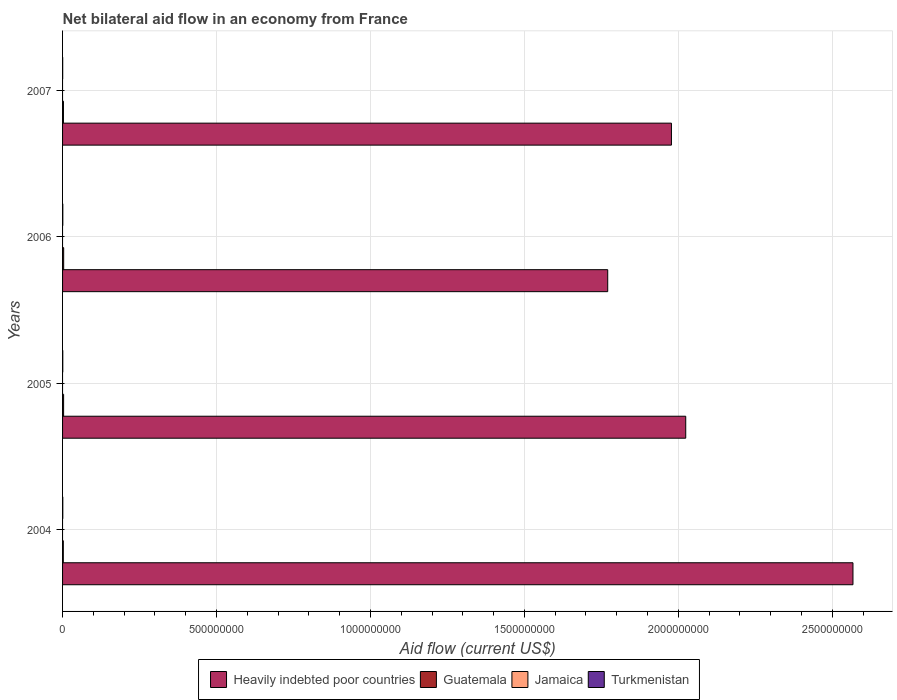How many different coloured bars are there?
Make the answer very short. 3. How many bars are there on the 4th tick from the top?
Ensure brevity in your answer.  3. What is the label of the 4th group of bars from the top?
Offer a terse response. 2004. What is the net bilateral aid flow in Turkmenistan in 2005?
Your answer should be compact. 6.80e+05. Across all years, what is the minimum net bilateral aid flow in Guatemala?
Your answer should be compact. 2.41e+06. In which year was the net bilateral aid flow in Turkmenistan maximum?
Make the answer very short. 2006. What is the total net bilateral aid flow in Guatemala in the graph?
Make the answer very short. 1.22e+07. What is the difference between the net bilateral aid flow in Guatemala in 2005 and that in 2007?
Keep it short and to the point. 5.10e+05. What is the difference between the net bilateral aid flow in Guatemala in 2005 and the net bilateral aid flow in Heavily indebted poor countries in 2007?
Offer a terse response. -1.97e+09. What is the average net bilateral aid flow in Guatemala per year?
Provide a short and direct response. 3.06e+06. In the year 2004, what is the difference between the net bilateral aid flow in Turkmenistan and net bilateral aid flow in Guatemala?
Your response must be concise. -1.64e+06. In how many years, is the net bilateral aid flow in Guatemala greater than 2000000000 US$?
Make the answer very short. 0. What is the ratio of the net bilateral aid flow in Turkmenistan in 2004 to that in 2006?
Offer a terse response. 0.96. What is the difference between the highest and the lowest net bilateral aid flow in Turkmenistan?
Your response must be concise. 4.20e+05. Is it the case that in every year, the sum of the net bilateral aid flow in Turkmenistan and net bilateral aid flow in Jamaica is greater than the net bilateral aid flow in Guatemala?
Keep it short and to the point. No. How many bars are there?
Ensure brevity in your answer.  12. Are all the bars in the graph horizontal?
Provide a succinct answer. Yes. Does the graph contain any zero values?
Keep it short and to the point. Yes. Does the graph contain grids?
Ensure brevity in your answer.  Yes. Where does the legend appear in the graph?
Offer a terse response. Bottom center. What is the title of the graph?
Offer a terse response. Net bilateral aid flow in an economy from France. What is the label or title of the X-axis?
Keep it short and to the point. Aid flow (current US$). What is the Aid flow (current US$) in Heavily indebted poor countries in 2004?
Your answer should be very brief. 2.57e+09. What is the Aid flow (current US$) of Guatemala in 2004?
Give a very brief answer. 2.41e+06. What is the Aid flow (current US$) of Jamaica in 2004?
Ensure brevity in your answer.  0. What is the Aid flow (current US$) of Turkmenistan in 2004?
Provide a short and direct response. 7.70e+05. What is the Aid flow (current US$) in Heavily indebted poor countries in 2005?
Your answer should be compact. 2.02e+09. What is the Aid flow (current US$) of Guatemala in 2005?
Provide a succinct answer. 3.37e+06. What is the Aid flow (current US$) of Turkmenistan in 2005?
Your response must be concise. 6.80e+05. What is the Aid flow (current US$) of Heavily indebted poor countries in 2006?
Your answer should be very brief. 1.77e+09. What is the Aid flow (current US$) in Guatemala in 2006?
Your response must be concise. 3.59e+06. What is the Aid flow (current US$) of Heavily indebted poor countries in 2007?
Offer a very short reply. 1.98e+09. What is the Aid flow (current US$) in Guatemala in 2007?
Keep it short and to the point. 2.86e+06. What is the Aid flow (current US$) in Jamaica in 2007?
Provide a short and direct response. 0. Across all years, what is the maximum Aid flow (current US$) of Heavily indebted poor countries?
Ensure brevity in your answer.  2.57e+09. Across all years, what is the maximum Aid flow (current US$) of Guatemala?
Your response must be concise. 3.59e+06. Across all years, what is the minimum Aid flow (current US$) of Heavily indebted poor countries?
Keep it short and to the point. 1.77e+09. Across all years, what is the minimum Aid flow (current US$) in Guatemala?
Keep it short and to the point. 2.41e+06. Across all years, what is the minimum Aid flow (current US$) of Turkmenistan?
Ensure brevity in your answer.  3.80e+05. What is the total Aid flow (current US$) of Heavily indebted poor countries in the graph?
Give a very brief answer. 8.34e+09. What is the total Aid flow (current US$) in Guatemala in the graph?
Your answer should be very brief. 1.22e+07. What is the total Aid flow (current US$) in Turkmenistan in the graph?
Your answer should be compact. 2.63e+06. What is the difference between the Aid flow (current US$) in Heavily indebted poor countries in 2004 and that in 2005?
Make the answer very short. 5.43e+08. What is the difference between the Aid flow (current US$) of Guatemala in 2004 and that in 2005?
Ensure brevity in your answer.  -9.60e+05. What is the difference between the Aid flow (current US$) in Turkmenistan in 2004 and that in 2005?
Your response must be concise. 9.00e+04. What is the difference between the Aid flow (current US$) of Heavily indebted poor countries in 2004 and that in 2006?
Make the answer very short. 7.97e+08. What is the difference between the Aid flow (current US$) in Guatemala in 2004 and that in 2006?
Your response must be concise. -1.18e+06. What is the difference between the Aid flow (current US$) of Heavily indebted poor countries in 2004 and that in 2007?
Ensure brevity in your answer.  5.90e+08. What is the difference between the Aid flow (current US$) in Guatemala in 2004 and that in 2007?
Keep it short and to the point. -4.50e+05. What is the difference between the Aid flow (current US$) in Heavily indebted poor countries in 2005 and that in 2006?
Provide a short and direct response. 2.53e+08. What is the difference between the Aid flow (current US$) in Heavily indebted poor countries in 2005 and that in 2007?
Provide a succinct answer. 4.64e+07. What is the difference between the Aid flow (current US$) in Guatemala in 2005 and that in 2007?
Provide a short and direct response. 5.10e+05. What is the difference between the Aid flow (current US$) in Heavily indebted poor countries in 2006 and that in 2007?
Your answer should be compact. -2.07e+08. What is the difference between the Aid flow (current US$) of Guatemala in 2006 and that in 2007?
Offer a very short reply. 7.30e+05. What is the difference between the Aid flow (current US$) in Heavily indebted poor countries in 2004 and the Aid flow (current US$) in Guatemala in 2005?
Give a very brief answer. 2.56e+09. What is the difference between the Aid flow (current US$) in Heavily indebted poor countries in 2004 and the Aid flow (current US$) in Turkmenistan in 2005?
Offer a very short reply. 2.57e+09. What is the difference between the Aid flow (current US$) of Guatemala in 2004 and the Aid flow (current US$) of Turkmenistan in 2005?
Make the answer very short. 1.73e+06. What is the difference between the Aid flow (current US$) in Heavily indebted poor countries in 2004 and the Aid flow (current US$) in Guatemala in 2006?
Give a very brief answer. 2.56e+09. What is the difference between the Aid flow (current US$) in Heavily indebted poor countries in 2004 and the Aid flow (current US$) in Turkmenistan in 2006?
Your answer should be very brief. 2.57e+09. What is the difference between the Aid flow (current US$) in Guatemala in 2004 and the Aid flow (current US$) in Turkmenistan in 2006?
Offer a terse response. 1.61e+06. What is the difference between the Aid flow (current US$) of Heavily indebted poor countries in 2004 and the Aid flow (current US$) of Guatemala in 2007?
Your response must be concise. 2.56e+09. What is the difference between the Aid flow (current US$) in Heavily indebted poor countries in 2004 and the Aid flow (current US$) in Turkmenistan in 2007?
Give a very brief answer. 2.57e+09. What is the difference between the Aid flow (current US$) of Guatemala in 2004 and the Aid flow (current US$) of Turkmenistan in 2007?
Provide a short and direct response. 2.03e+06. What is the difference between the Aid flow (current US$) of Heavily indebted poor countries in 2005 and the Aid flow (current US$) of Guatemala in 2006?
Your answer should be very brief. 2.02e+09. What is the difference between the Aid flow (current US$) in Heavily indebted poor countries in 2005 and the Aid flow (current US$) in Turkmenistan in 2006?
Provide a succinct answer. 2.02e+09. What is the difference between the Aid flow (current US$) in Guatemala in 2005 and the Aid flow (current US$) in Turkmenistan in 2006?
Provide a short and direct response. 2.57e+06. What is the difference between the Aid flow (current US$) in Heavily indebted poor countries in 2005 and the Aid flow (current US$) in Guatemala in 2007?
Keep it short and to the point. 2.02e+09. What is the difference between the Aid flow (current US$) in Heavily indebted poor countries in 2005 and the Aid flow (current US$) in Turkmenistan in 2007?
Your response must be concise. 2.02e+09. What is the difference between the Aid flow (current US$) in Guatemala in 2005 and the Aid flow (current US$) in Turkmenistan in 2007?
Offer a very short reply. 2.99e+06. What is the difference between the Aid flow (current US$) in Heavily indebted poor countries in 2006 and the Aid flow (current US$) in Guatemala in 2007?
Offer a terse response. 1.77e+09. What is the difference between the Aid flow (current US$) of Heavily indebted poor countries in 2006 and the Aid flow (current US$) of Turkmenistan in 2007?
Offer a terse response. 1.77e+09. What is the difference between the Aid flow (current US$) of Guatemala in 2006 and the Aid flow (current US$) of Turkmenistan in 2007?
Your answer should be very brief. 3.21e+06. What is the average Aid flow (current US$) of Heavily indebted poor countries per year?
Your answer should be compact. 2.08e+09. What is the average Aid flow (current US$) of Guatemala per year?
Your answer should be compact. 3.06e+06. What is the average Aid flow (current US$) in Jamaica per year?
Make the answer very short. 0. What is the average Aid flow (current US$) of Turkmenistan per year?
Provide a short and direct response. 6.58e+05. In the year 2004, what is the difference between the Aid flow (current US$) of Heavily indebted poor countries and Aid flow (current US$) of Guatemala?
Your answer should be compact. 2.56e+09. In the year 2004, what is the difference between the Aid flow (current US$) in Heavily indebted poor countries and Aid flow (current US$) in Turkmenistan?
Your answer should be very brief. 2.57e+09. In the year 2004, what is the difference between the Aid flow (current US$) in Guatemala and Aid flow (current US$) in Turkmenistan?
Offer a very short reply. 1.64e+06. In the year 2005, what is the difference between the Aid flow (current US$) of Heavily indebted poor countries and Aid flow (current US$) of Guatemala?
Your answer should be very brief. 2.02e+09. In the year 2005, what is the difference between the Aid flow (current US$) in Heavily indebted poor countries and Aid flow (current US$) in Turkmenistan?
Your response must be concise. 2.02e+09. In the year 2005, what is the difference between the Aid flow (current US$) of Guatemala and Aid flow (current US$) of Turkmenistan?
Your response must be concise. 2.69e+06. In the year 2006, what is the difference between the Aid flow (current US$) of Heavily indebted poor countries and Aid flow (current US$) of Guatemala?
Provide a succinct answer. 1.77e+09. In the year 2006, what is the difference between the Aid flow (current US$) of Heavily indebted poor countries and Aid flow (current US$) of Turkmenistan?
Make the answer very short. 1.77e+09. In the year 2006, what is the difference between the Aid flow (current US$) of Guatemala and Aid flow (current US$) of Turkmenistan?
Give a very brief answer. 2.79e+06. In the year 2007, what is the difference between the Aid flow (current US$) of Heavily indebted poor countries and Aid flow (current US$) of Guatemala?
Provide a succinct answer. 1.97e+09. In the year 2007, what is the difference between the Aid flow (current US$) in Heavily indebted poor countries and Aid flow (current US$) in Turkmenistan?
Your response must be concise. 1.98e+09. In the year 2007, what is the difference between the Aid flow (current US$) in Guatemala and Aid flow (current US$) in Turkmenistan?
Your answer should be very brief. 2.48e+06. What is the ratio of the Aid flow (current US$) of Heavily indebted poor countries in 2004 to that in 2005?
Provide a succinct answer. 1.27. What is the ratio of the Aid flow (current US$) of Guatemala in 2004 to that in 2005?
Ensure brevity in your answer.  0.72. What is the ratio of the Aid flow (current US$) in Turkmenistan in 2004 to that in 2005?
Make the answer very short. 1.13. What is the ratio of the Aid flow (current US$) of Heavily indebted poor countries in 2004 to that in 2006?
Offer a terse response. 1.45. What is the ratio of the Aid flow (current US$) in Guatemala in 2004 to that in 2006?
Offer a very short reply. 0.67. What is the ratio of the Aid flow (current US$) of Turkmenistan in 2004 to that in 2006?
Ensure brevity in your answer.  0.96. What is the ratio of the Aid flow (current US$) in Heavily indebted poor countries in 2004 to that in 2007?
Give a very brief answer. 1.3. What is the ratio of the Aid flow (current US$) of Guatemala in 2004 to that in 2007?
Offer a terse response. 0.84. What is the ratio of the Aid flow (current US$) of Turkmenistan in 2004 to that in 2007?
Offer a very short reply. 2.03. What is the ratio of the Aid flow (current US$) in Heavily indebted poor countries in 2005 to that in 2006?
Provide a succinct answer. 1.14. What is the ratio of the Aid flow (current US$) of Guatemala in 2005 to that in 2006?
Give a very brief answer. 0.94. What is the ratio of the Aid flow (current US$) of Turkmenistan in 2005 to that in 2006?
Your answer should be compact. 0.85. What is the ratio of the Aid flow (current US$) of Heavily indebted poor countries in 2005 to that in 2007?
Your answer should be very brief. 1.02. What is the ratio of the Aid flow (current US$) of Guatemala in 2005 to that in 2007?
Your response must be concise. 1.18. What is the ratio of the Aid flow (current US$) of Turkmenistan in 2005 to that in 2007?
Ensure brevity in your answer.  1.79. What is the ratio of the Aid flow (current US$) in Heavily indebted poor countries in 2006 to that in 2007?
Your answer should be compact. 0.9. What is the ratio of the Aid flow (current US$) in Guatemala in 2006 to that in 2007?
Offer a very short reply. 1.26. What is the ratio of the Aid flow (current US$) of Turkmenistan in 2006 to that in 2007?
Keep it short and to the point. 2.11. What is the difference between the highest and the second highest Aid flow (current US$) of Heavily indebted poor countries?
Ensure brevity in your answer.  5.43e+08. What is the difference between the highest and the lowest Aid flow (current US$) in Heavily indebted poor countries?
Your response must be concise. 7.97e+08. What is the difference between the highest and the lowest Aid flow (current US$) in Guatemala?
Your answer should be very brief. 1.18e+06. What is the difference between the highest and the lowest Aid flow (current US$) of Turkmenistan?
Offer a very short reply. 4.20e+05. 